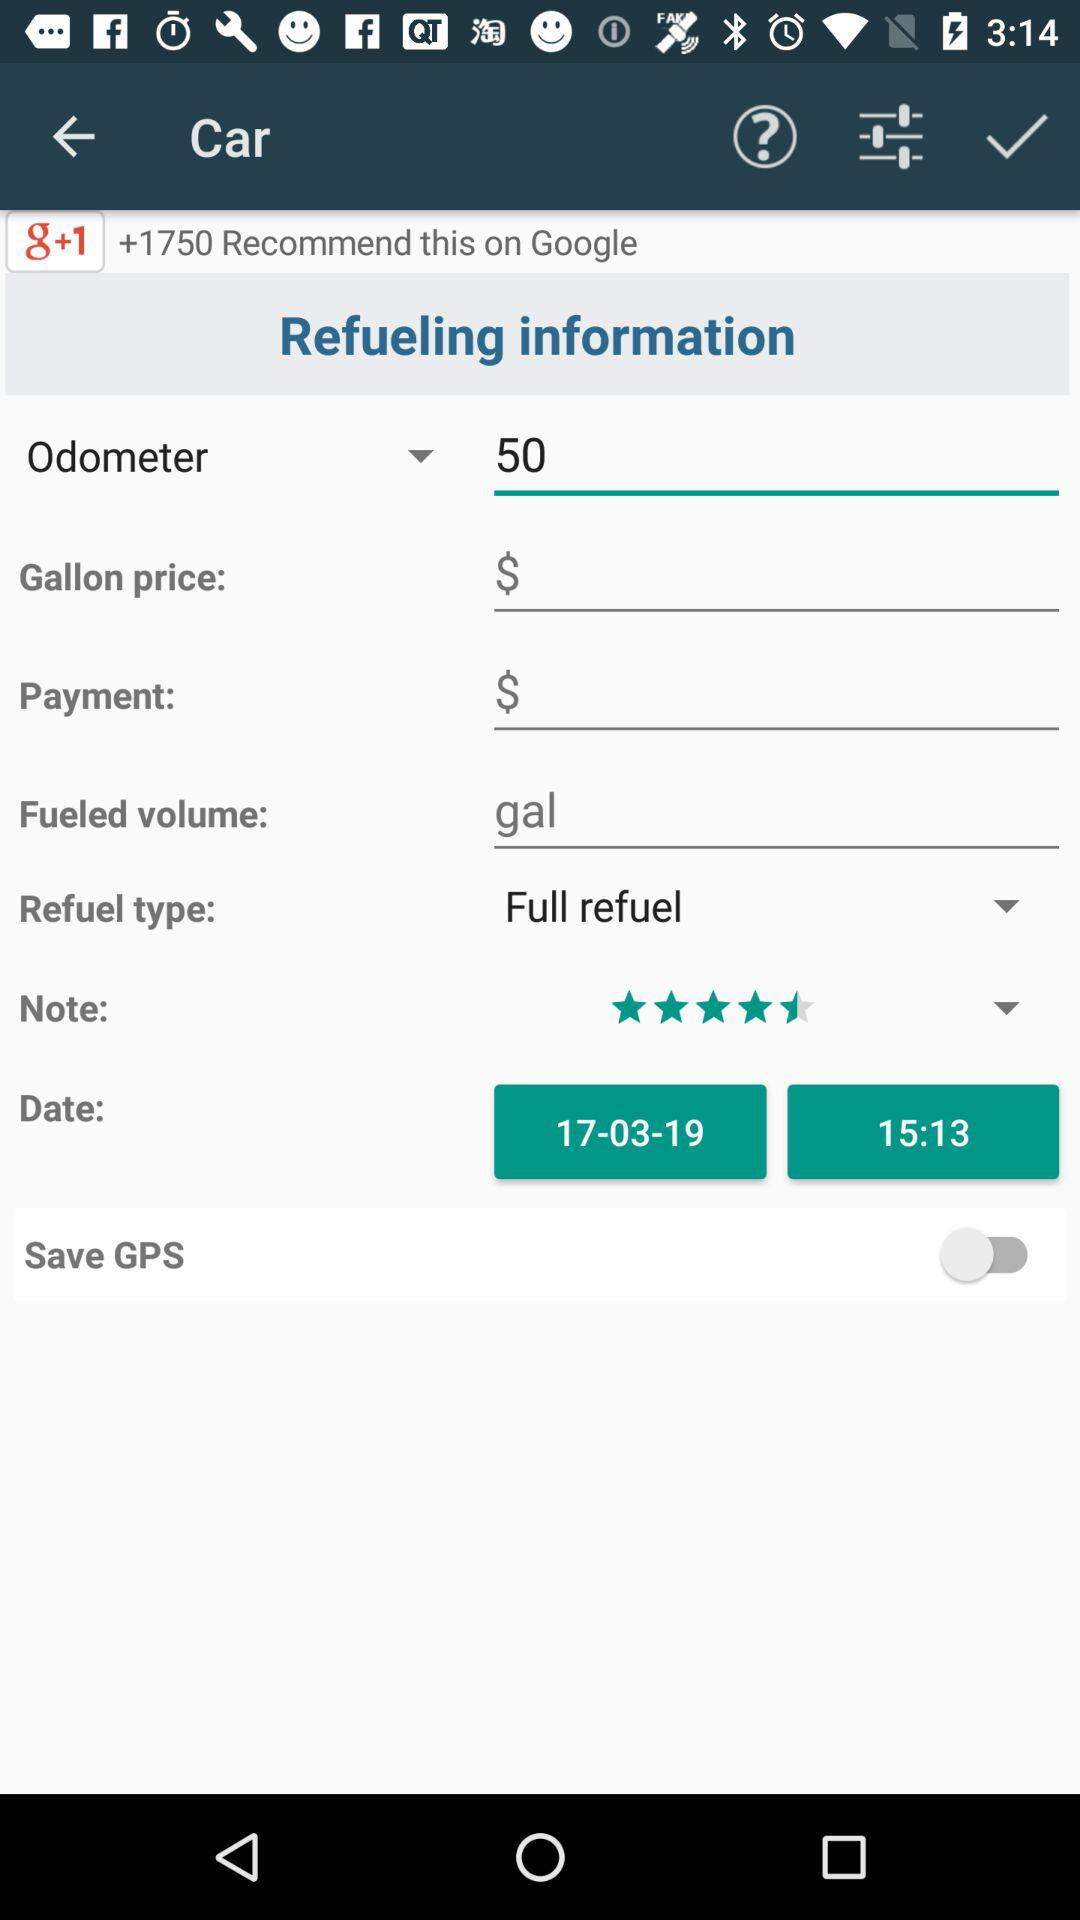Which date is shown on the screen? The shown date on the screen is March 17, 2019. 